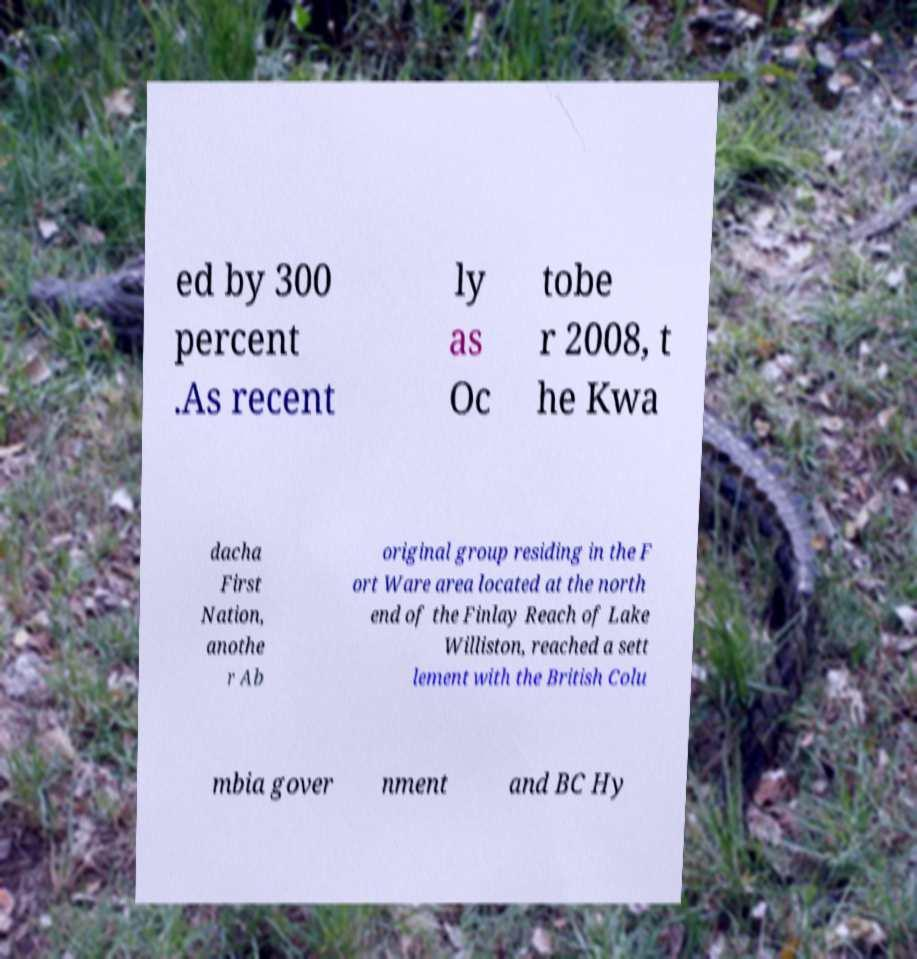For documentation purposes, I need the text within this image transcribed. Could you provide that? ed by 300 percent .As recent ly as Oc tobe r 2008, t he Kwa dacha First Nation, anothe r Ab original group residing in the F ort Ware area located at the north end of the Finlay Reach of Lake Williston, reached a sett lement with the British Colu mbia gover nment and BC Hy 